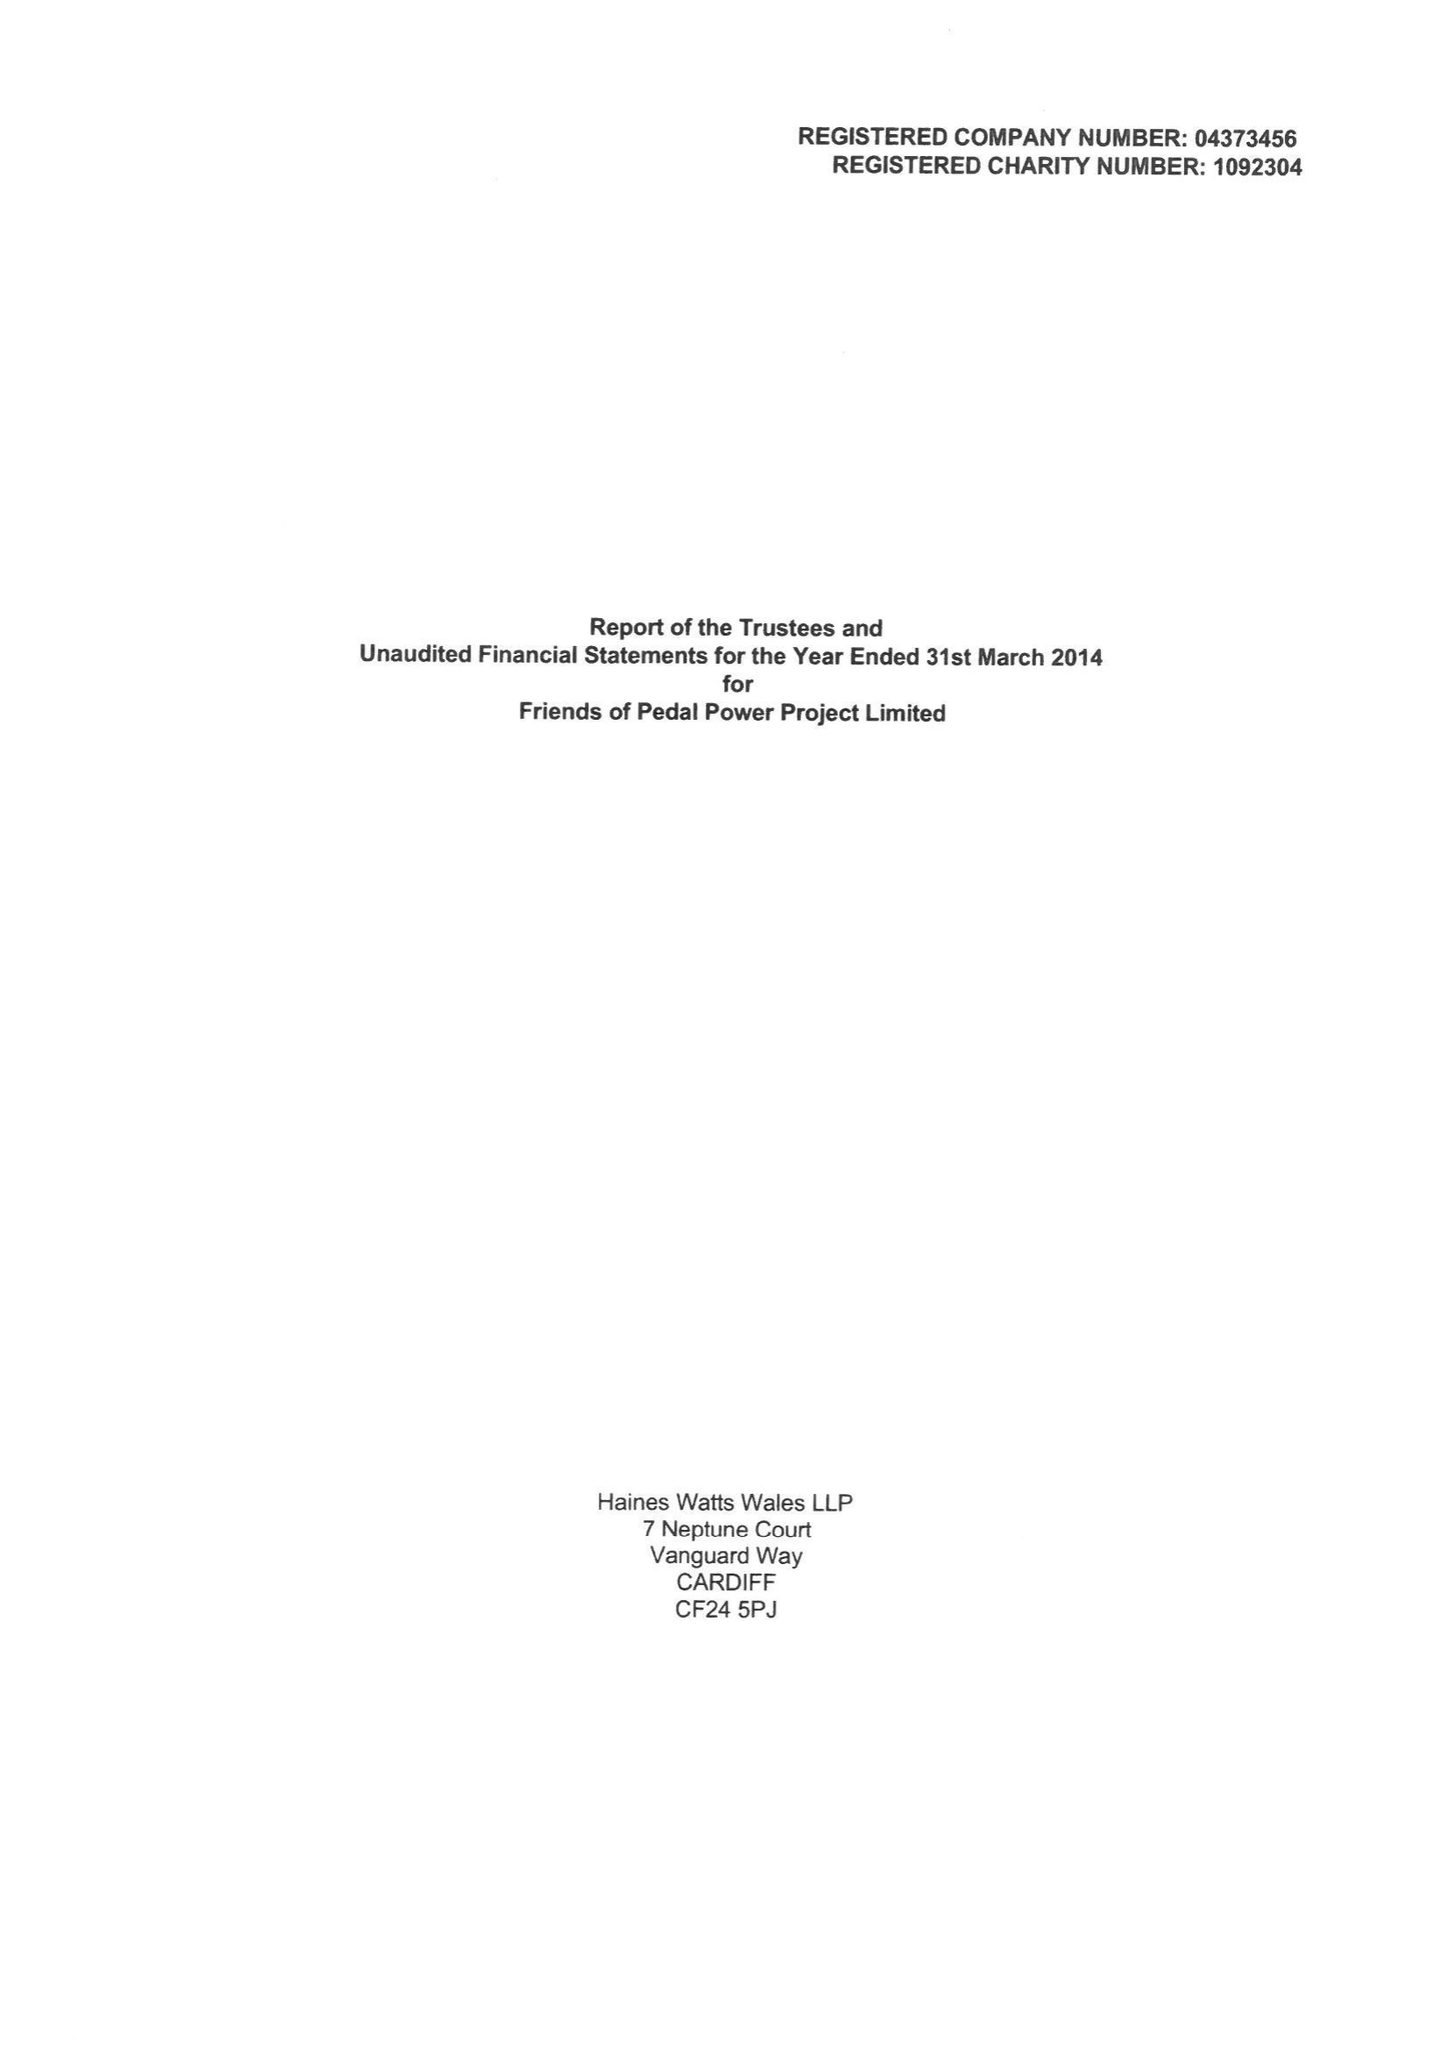What is the value for the charity_name?
Answer the question using a single word or phrase. Friends Of Pedal Power Project Ltd. 